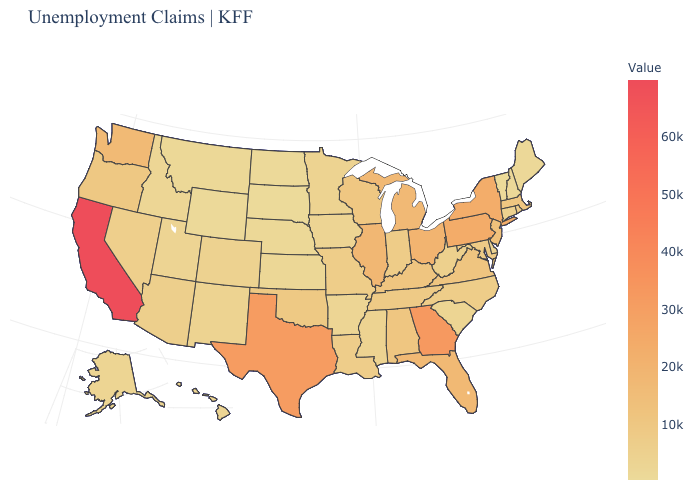Which states hav the highest value in the West?
Quick response, please. California. Which states have the lowest value in the MidWest?
Quick response, please. South Dakota. Among the states that border Pennsylvania , which have the highest value?
Answer briefly. New York. Which states hav the highest value in the South?
Be succinct. Georgia. Does New Hampshire have a higher value than California?
Answer briefly. No. Among the states that border Massachusetts , which have the lowest value?
Keep it brief. Vermont. 